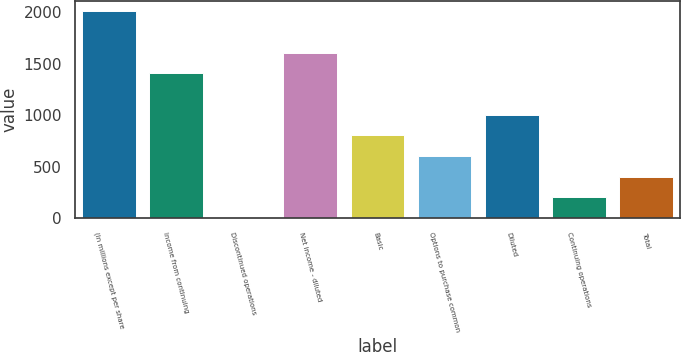Convert chart to OTSL. <chart><loc_0><loc_0><loc_500><loc_500><bar_chart><fcel>(In millions except per share<fcel>Income from continuing<fcel>Discontinued operations<fcel>Net income - diluted<fcel>Basic<fcel>Options to purchase common<fcel>Diluted<fcel>Continuing operations<fcel>Total<nl><fcel>2008<fcel>1405.9<fcel>1<fcel>1606.6<fcel>803.8<fcel>603.1<fcel>1004.5<fcel>201.7<fcel>402.4<nl></chart> 